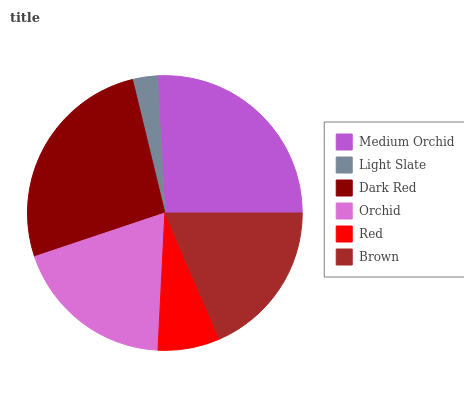Is Light Slate the minimum?
Answer yes or no. Yes. Is Dark Red the maximum?
Answer yes or no. Yes. Is Dark Red the minimum?
Answer yes or no. No. Is Light Slate the maximum?
Answer yes or no. No. Is Dark Red greater than Light Slate?
Answer yes or no. Yes. Is Light Slate less than Dark Red?
Answer yes or no. Yes. Is Light Slate greater than Dark Red?
Answer yes or no. No. Is Dark Red less than Light Slate?
Answer yes or no. No. Is Orchid the high median?
Answer yes or no. Yes. Is Brown the low median?
Answer yes or no. Yes. Is Medium Orchid the high median?
Answer yes or no. No. Is Light Slate the low median?
Answer yes or no. No. 